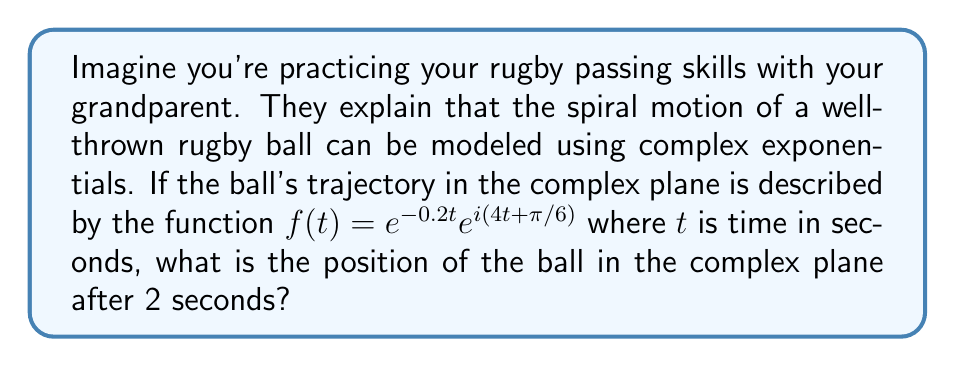Can you answer this question? Let's break this down step-by-step:

1) The given function is $f(t) = e^{-0.2t}e^{i(4t+\pi/6)}$

2) This can be rewritten as a product of two parts:
   - $e^{-0.2t}$ : This part represents the decreasing amplitude of the spiral
   - $e^{i(4t+\pi/6)}$ : This part represents the rotational motion

3) We need to find $f(2)$, so let's substitute $t=2$ into our function:

   $f(2) = e^{-0.2(2)}e^{i(4(2)+\pi/6)}$

4) Simplify the exponents:
   $f(2) = e^{-0.4}e^{i(8+\pi/6)}$

5) We can separate this into polar form:
   $r = e^{-0.4}$ (magnitude)
   $\theta = 8 + \pi/6$ (angle in radians)

6) Calculate the magnitude:
   $r = e^{-0.4} \approx 0.6703$

7) Calculate the angle:
   $\theta = 8 + \pi/6 \approx 8.5236$ radians

8) To convert from polar to rectangular form, we use:
   $x = r \cos(\theta)$
   $y = r \sin(\theta)$

9) Calculating:
   $x \approx 0.6703 \cos(8.5236) \approx -0.1924$
   $y \approx 0.6703 \sin(8.5236) \approx 0.6431$

Therefore, after 2 seconds, the ball's position in the complex plane is approximately $-0.1924 + 0.6431i$.
Answer: $f(2) \approx -0.1924 + 0.6431i$ 